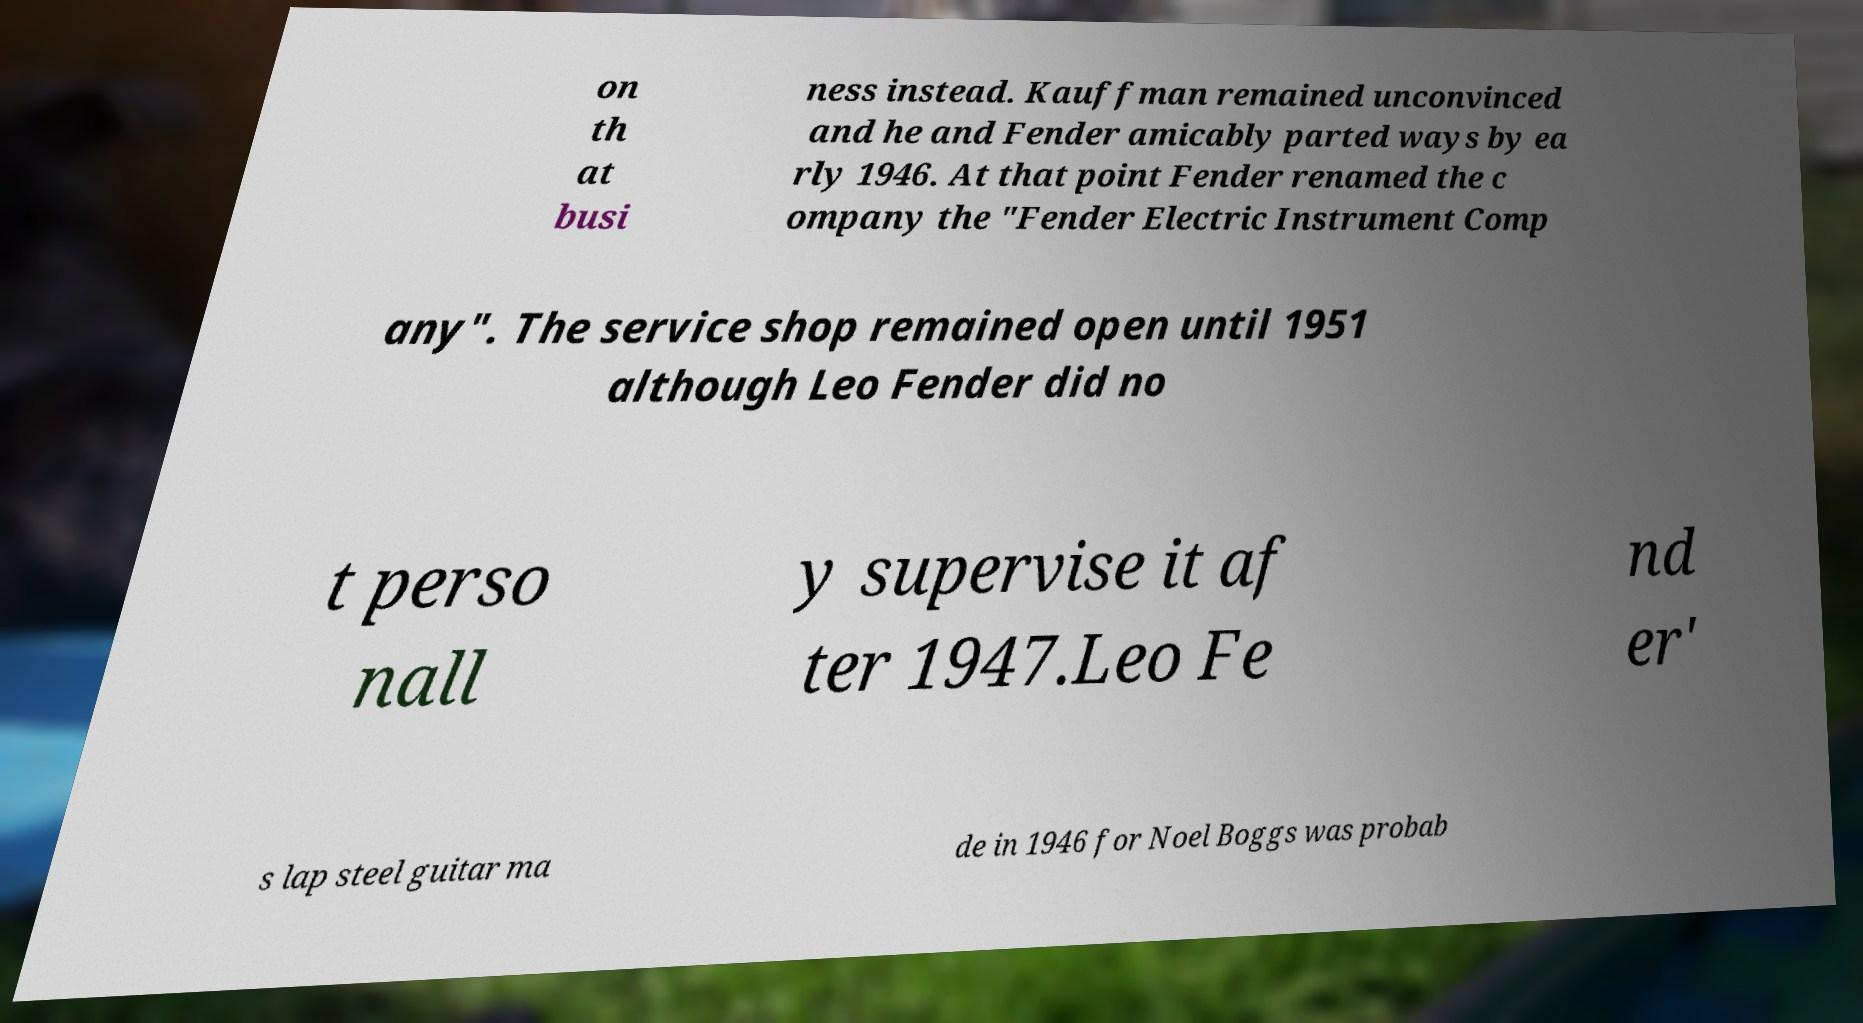Please read and relay the text visible in this image. What does it say? on th at busi ness instead. Kauffman remained unconvinced and he and Fender amicably parted ways by ea rly 1946. At that point Fender renamed the c ompany the "Fender Electric Instrument Comp any". The service shop remained open until 1951 although Leo Fender did no t perso nall y supervise it af ter 1947.Leo Fe nd er' s lap steel guitar ma de in 1946 for Noel Boggs was probab 